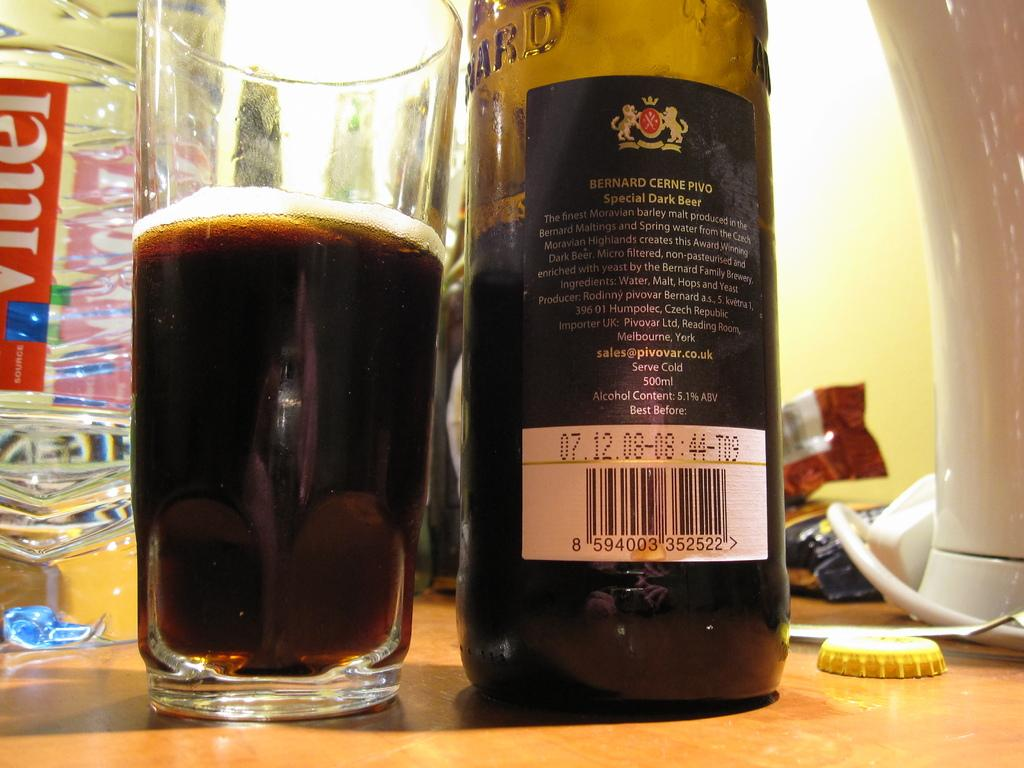Provide a one-sentence caption for the provided image. A cup full of beer and a bottle of beer are next to each other. 